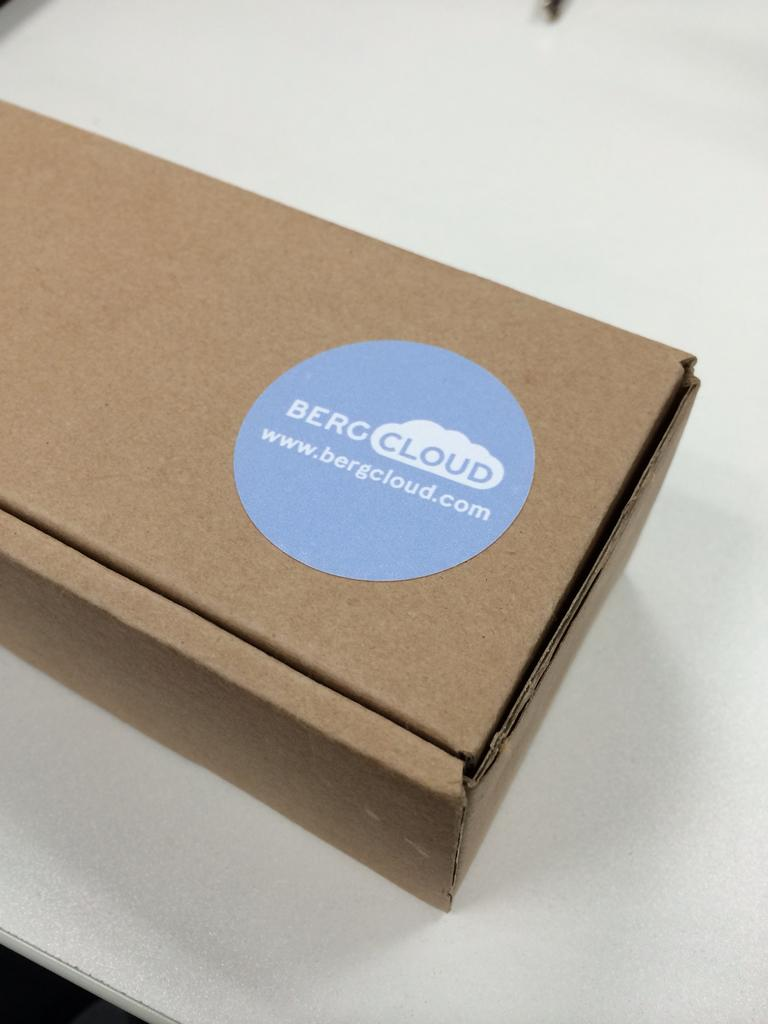<image>
Relay a brief, clear account of the picture shown. A box has a blue sticker that says Berc Cloud. 